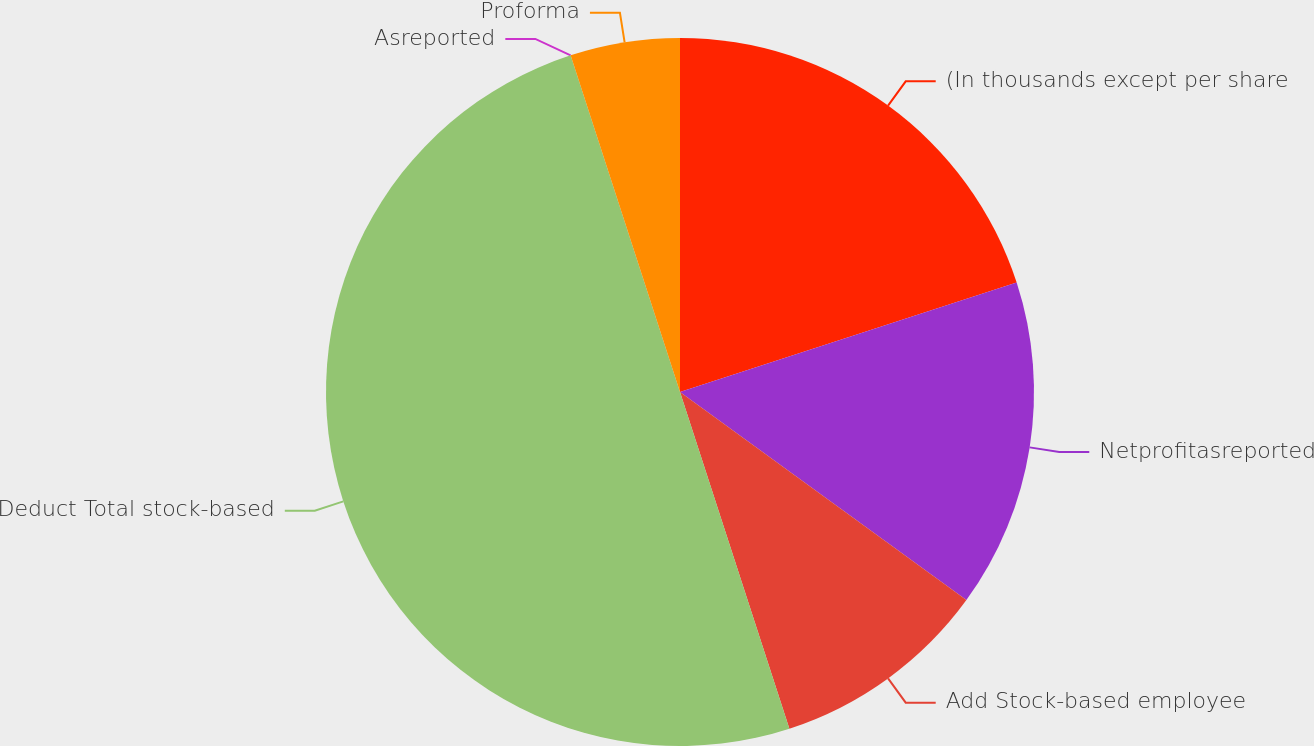Convert chart to OTSL. <chart><loc_0><loc_0><loc_500><loc_500><pie_chart><fcel>(In thousands except per share<fcel>Netprofitasreported<fcel>Add Stock-based employee<fcel>Deduct Total stock-based<fcel>Asreported<fcel>Proforma<nl><fcel>20.0%<fcel>15.0%<fcel>10.0%<fcel>50.0%<fcel>0.0%<fcel>5.0%<nl></chart> 